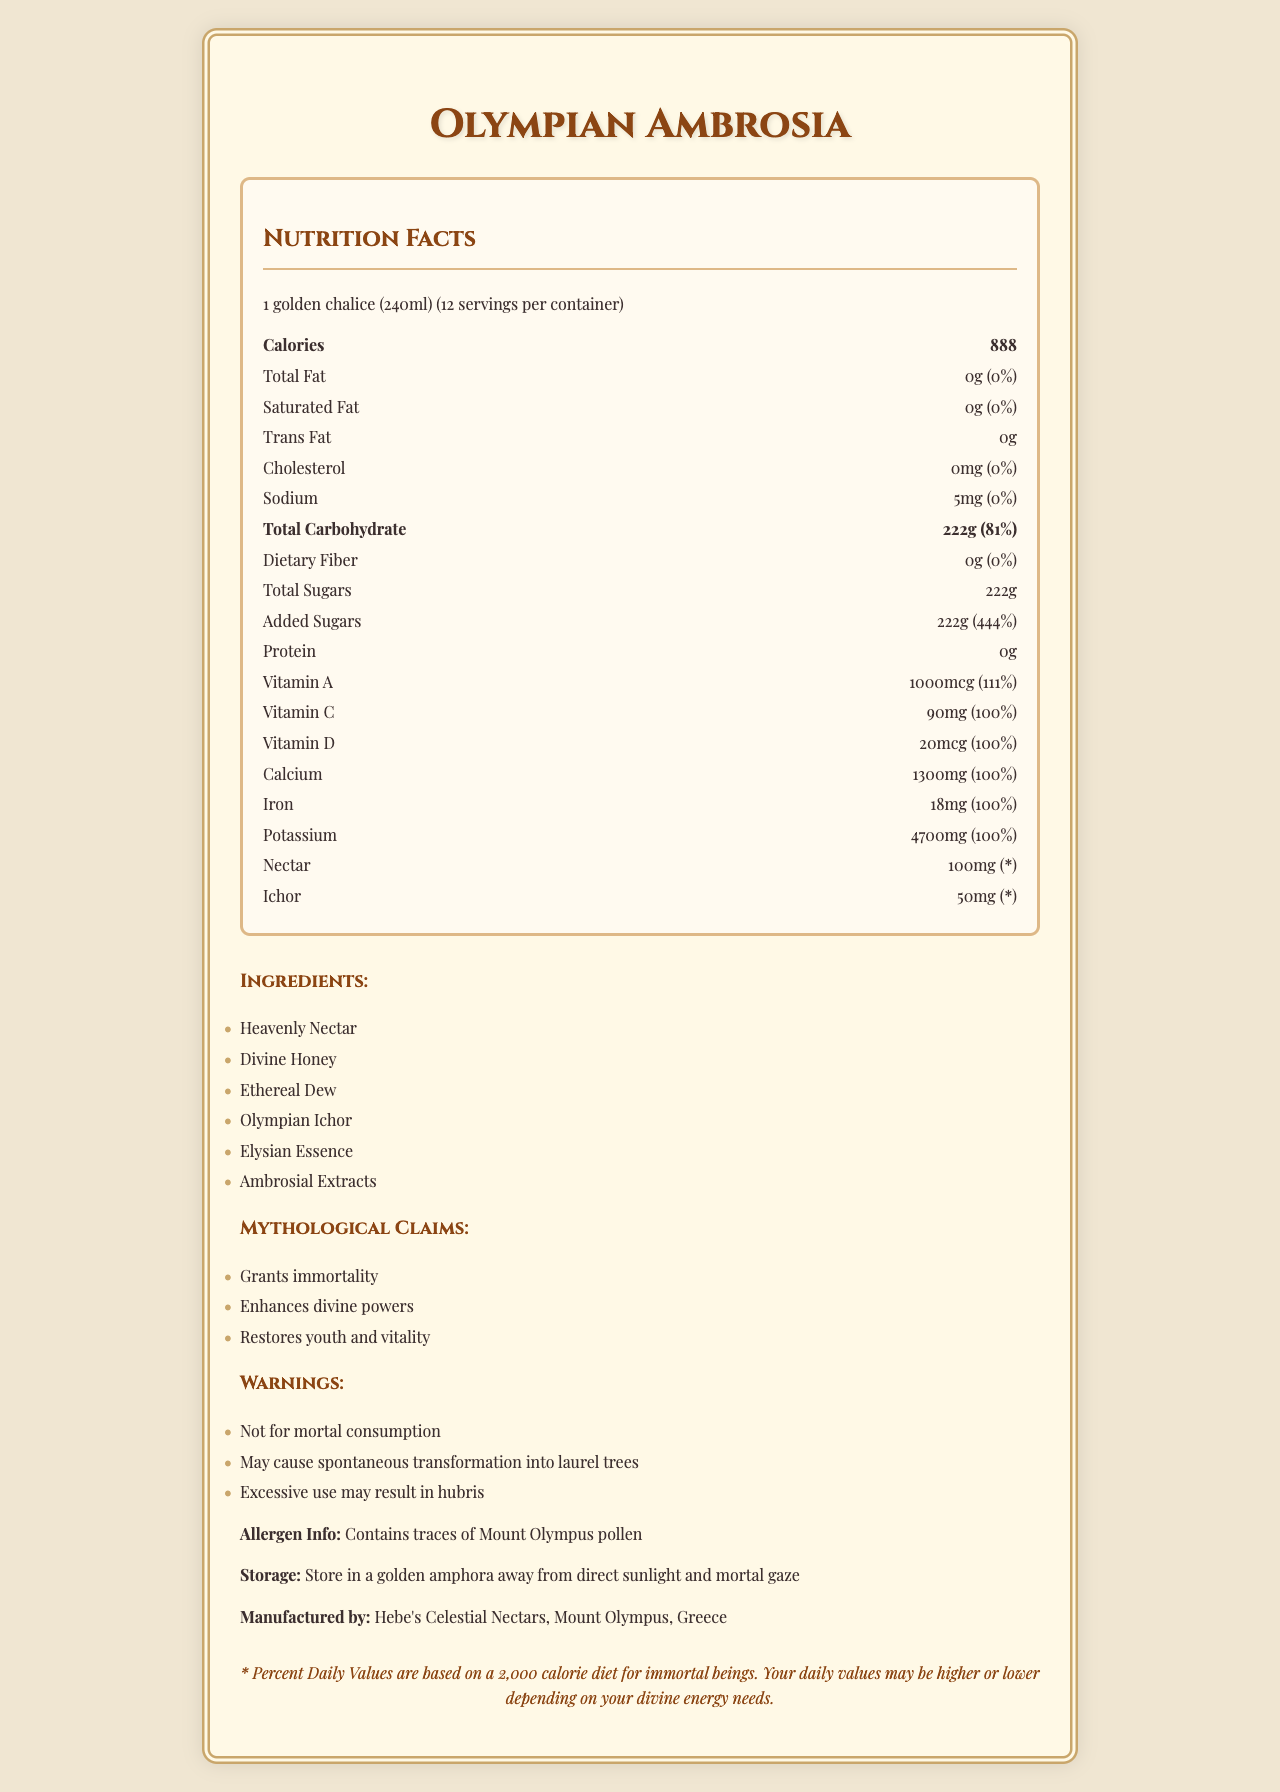what is the serving size for Olympian Ambrosia? According to the document, the serving size specified for Olympian Ambrosia is 1 golden chalice, which equals 240ml.
Answer: 1 golden chalice (240ml) how many servings are there per container of Olympian Ambrosia? The document states that there are 12 servings per container.
Answer: 12 how many calories are there per serving? The document lists the calorie content per serving as 888.
Answer: 888 what is the total carbohydrate content per serving? The total carbohydrate content per serving is given as 222g.
Answer: 222g what are the mythological claims associated with Olympian Ambrosia? The mythological claims listed in the document are "Grants immortality," "Enhances divine powers," and "Restores youth and vitality."
Answer: Grants immortality, Enhances divine powers, Restores youth and vitality which of the following allergies might be triggered by Olympian Ambrosia? A. Tree nuts B. Mount Olympus pollen C. Gluten The allergen information section mentions that the product contains traces of Mount Olympus pollen.
Answer: B. Mount Olympus pollen which of these warnings is stated in the document? A. May cause indigestion B. Not for mortal consumption C. Seek medical advice before use One of the warnings provided in the document is "Not for mortal consumption."
Answer: B. Not for mortal consumption is there any dietary fiber in Olympian Ambrosia? The document states that the dietary fiber content is 0g.
Answer: No can Olympian Ambrosia grant immortality? While the document lists "Grants immortality" as a mythological claim, it cannot be verified based on the visual information provided.
Answer: Cannot be determined what should be used to store Olympian Ambrosia? The storage instructions advise keeping the product in a golden amphora away from direct sunlight and mortal gaze.
Answer: A golden amphora does Olympian Ambrosia contain any forms of fat? The document lists the total fat, saturated fat, and trans fat content as 0g.
Answer: No summarize the main nutritional components and other information in the document. The summary must encompass the range of nutritional components, mythological claims, and the specific details provided in the document, including calorie count, fat content, carbohydrate content, allergen information, and storage instructions.
Answer: Olympian Ambrosia offers a range of nutritional benefits, such as 888 calories per serving, and it is rich in carbohydrates and several essential vitamins and minerals. The product is made from divine ingredients, carries mythological claims of granting immortality and enhancing divine powers, and comes with specific storage instructions and warnings. 